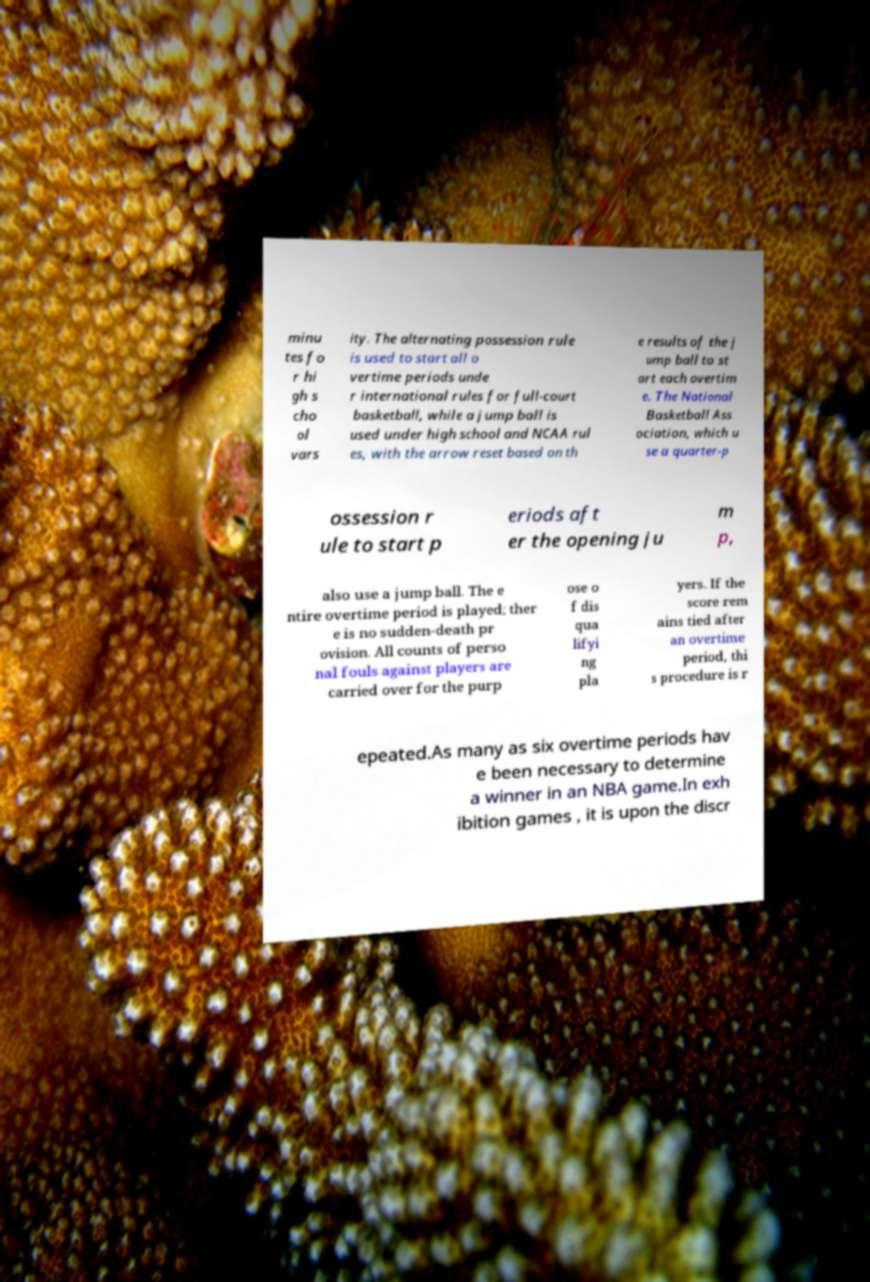Please read and relay the text visible in this image. What does it say? minu tes fo r hi gh s cho ol vars ity. The alternating possession rule is used to start all o vertime periods unde r international rules for full-court basketball, while a jump ball is used under high school and NCAA rul es, with the arrow reset based on th e results of the j ump ball to st art each overtim e. The National Basketball Ass ociation, which u se a quarter-p ossession r ule to start p eriods aft er the opening ju m p, also use a jump ball. The e ntire overtime period is played; ther e is no sudden-death pr ovision. All counts of perso nal fouls against players are carried over for the purp ose o f dis qua lifyi ng pla yers. If the score rem ains tied after an overtime period, thi s procedure is r epeated.As many as six overtime periods hav e been necessary to determine a winner in an NBA game.In exh ibition games , it is upon the discr 